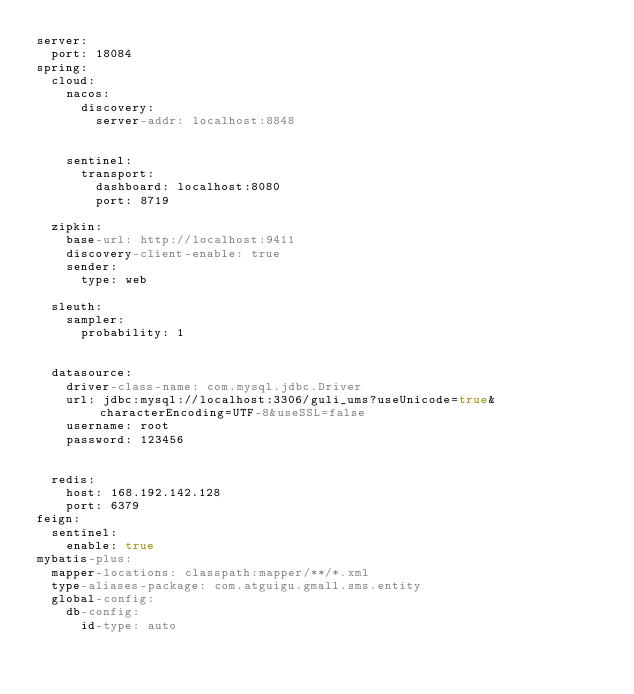<code> <loc_0><loc_0><loc_500><loc_500><_YAML_>server:
  port: 18084
spring:
  cloud:
    nacos:
      discovery:
        server-addr: localhost:8848


    sentinel:
      transport:
        dashboard: localhost:8080
        port: 8719

  zipkin:
    base-url: http://localhost:9411
    discovery-client-enable: true
    sender:
      type: web

  sleuth:
    sampler:
      probability: 1


  datasource:
    driver-class-name: com.mysql.jdbc.Driver
    url: jdbc:mysql://localhost:3306/guli_ums?useUnicode=true&characterEncoding=UTF-8&useSSL=false
    username: root
    password: 123456


  redis:
    host: 168.192.142.128
    port: 6379
feign:
  sentinel:
    enable: true
mybatis-plus:
  mapper-locations: classpath:mapper/**/*.xml
  type-aliases-package: com.atguigu.gmall.sms.entity
  global-config:
    db-config:
      id-type: auto
</code> 